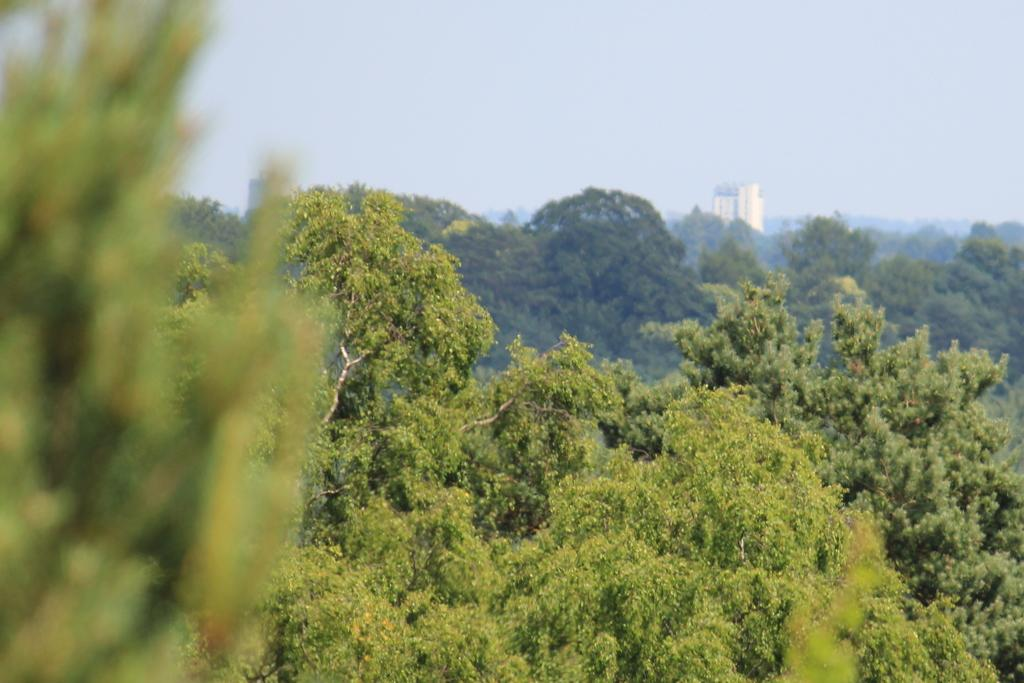What type of natural elements can be seen in the image? There are many trees in the image. What part of the natural environment is visible in the image? The sky is visible in the image. What type of man-made structure is present in the image? There is a big building in the image. Can you tell me how many zippers are on the trees in the image? There are no zippers present on the trees in the image, as zippers are not a natural part of trees. 